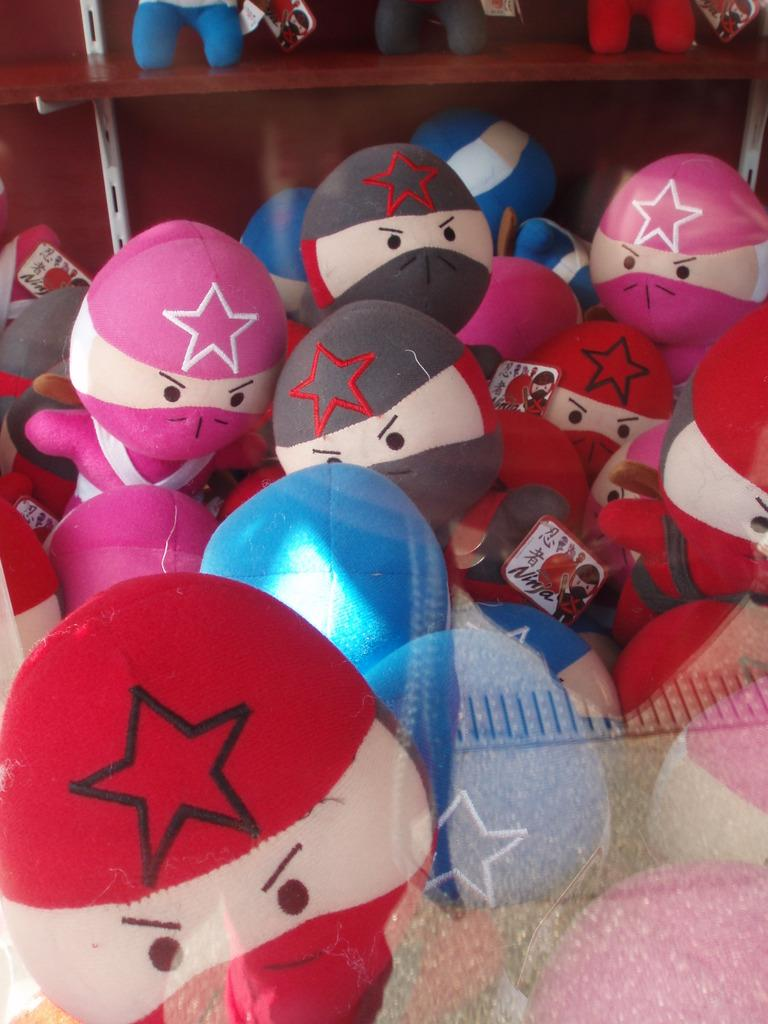What can be seen in abundance in the image? There are many toys in the image. What is visible in the background of the image? There is a cupboard in the background of the image. Where are some of the toys located? Some of the toys are inside the cupboard. What type of waves can be seen crashing against the shore in the image? There are no waves or shore visible in the image; it features toys and a cupboard. 